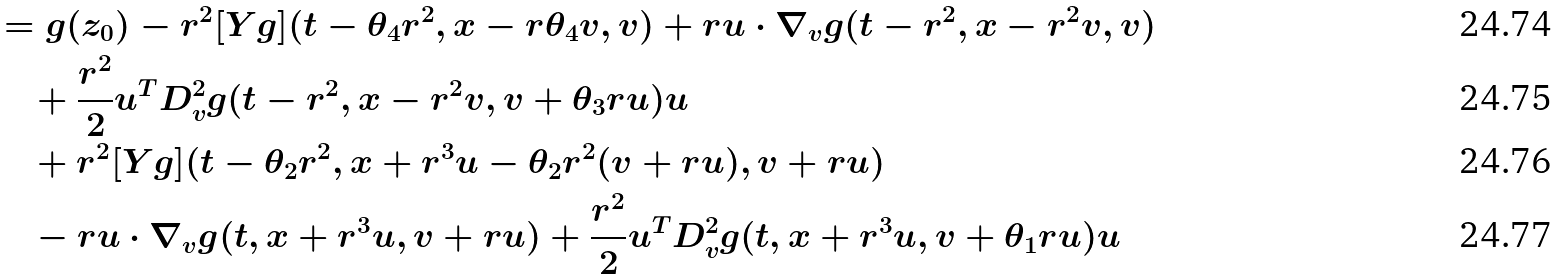<formula> <loc_0><loc_0><loc_500><loc_500>& = g ( z _ { 0 } ) - r ^ { 2 } [ Y g ] ( t - \theta _ { 4 } r ^ { 2 } , x - r \theta _ { 4 } v , v ) + r u \cdot \nabla _ { v } g ( t - r ^ { 2 } , x - r ^ { 2 } v , v ) \\ & \quad + \frac { r ^ { 2 } } { 2 } u ^ { T } D ^ { 2 } _ { v } g ( t - r ^ { 2 } , x - r ^ { 2 } v , v + \theta _ { 3 } r u ) u \\ & \quad + r ^ { 2 } [ Y g ] ( t - \theta _ { 2 } r ^ { 2 } , x + r ^ { 3 } u - \theta _ { 2 } r ^ { 2 } ( v + r u ) , v + r u ) \\ & \quad - r u \cdot \nabla _ { v } g ( t , x + r ^ { 3 } u , v + r u ) + \frac { r ^ { 2 } } { 2 } u ^ { T } D ^ { 2 } _ { v } g ( t , x + r ^ { 3 } u , v + \theta _ { 1 } r u ) u</formula> 